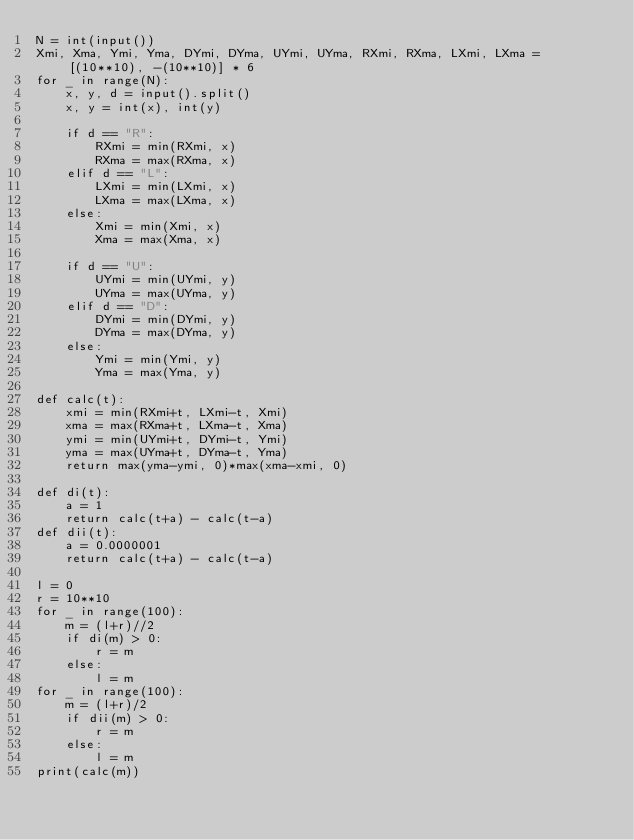<code> <loc_0><loc_0><loc_500><loc_500><_Python_>N = int(input())
Xmi, Xma, Ymi, Yma, DYmi, DYma, UYmi, UYma, RXmi, RXma, LXmi, LXma = [(10**10), -(10**10)] * 6
for _ in range(N):
    x, y, d = input().split()
    x, y = int(x), int(y)
    
    if d == "R":
        RXmi = min(RXmi, x)
        RXma = max(RXma, x)
    elif d == "L":
        LXmi = min(LXmi, x)
        LXma = max(LXma, x)
    else:
        Xmi = min(Xmi, x)
        Xma = max(Xma, x)
        
    if d == "U":
        UYmi = min(UYmi, y)
        UYma = max(UYma, y)
    elif d == "D":
        DYmi = min(DYmi, y)
        DYma = max(DYma, y)
    else:
        Ymi = min(Ymi, y)
        Yma = max(Yma, y)

def calc(t):
    xmi = min(RXmi+t, LXmi-t, Xmi)
    xma = max(RXma+t, LXma-t, Xma)
    ymi = min(UYmi+t, DYmi-t, Ymi)
    yma = max(UYma+t, DYma-t, Yma)
    return max(yma-ymi, 0)*max(xma-xmi, 0)
    
def di(t):
    a = 1
    return calc(t+a) - calc(t-a)
def dii(t):
    a = 0.0000001
    return calc(t+a) - calc(t-a)

l = 0
r = 10**10
for _ in range(100):
    m = (l+r)//2
    if di(m) > 0:
        r = m
    else:
        l = m
for _ in range(100):
    m = (l+r)/2
    if dii(m) > 0:
        r = m
    else:
        l = m
print(calc(m))
</code> 